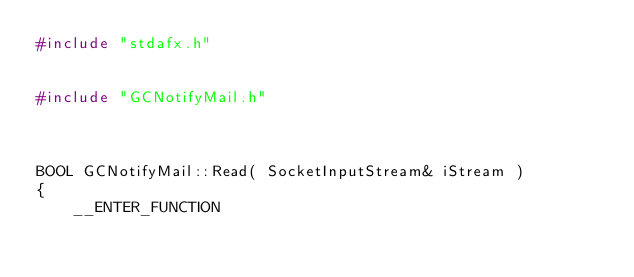Convert code to text. <code><loc_0><loc_0><loc_500><loc_500><_C++_>#include "stdafx.h"


#include "GCNotifyMail.h"



BOOL GCNotifyMail::Read( SocketInputStream& iStream ) 
{
	__ENTER_FUNCTION
</code> 